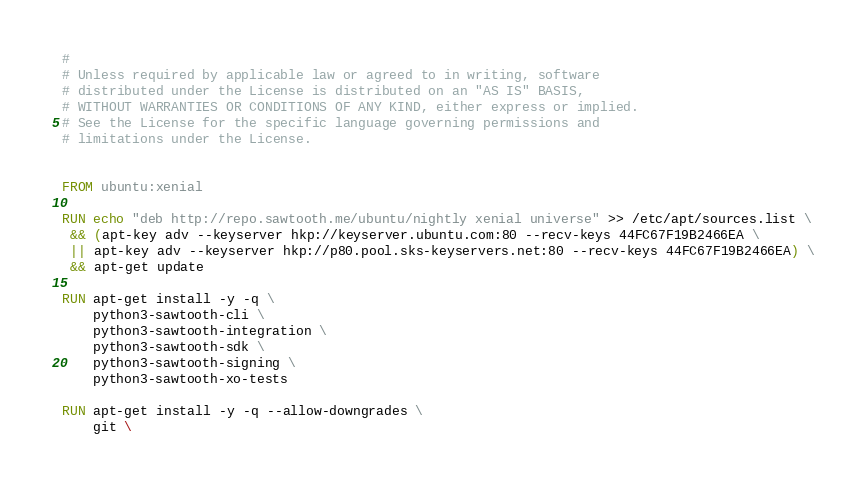<code> <loc_0><loc_0><loc_500><loc_500><_Dockerfile_>#
# Unless required by applicable law or agreed to in writing, software
# distributed under the License is distributed on an "AS IS" BASIS,
# WITHOUT WARRANTIES OR CONDITIONS OF ANY KIND, either express or implied.
# See the License for the specific language governing permissions and
# limitations under the License.


FROM ubuntu:xenial

RUN echo "deb http://repo.sawtooth.me/ubuntu/nightly xenial universe" >> /etc/apt/sources.list \
 && (apt-key adv --keyserver hkp://keyserver.ubuntu.com:80 --recv-keys 44FC67F19B2466EA \
 || apt-key adv --keyserver hkp://p80.pool.sks-keyservers.net:80 --recv-keys 44FC67F19B2466EA) \
 && apt-get update

RUN apt-get install -y -q \
    python3-sawtooth-cli \
    python3-sawtooth-integration \
    python3-sawtooth-sdk \
    python3-sawtooth-signing \
    python3-sawtooth-xo-tests

RUN apt-get install -y -q --allow-downgrades \
    git \</code> 